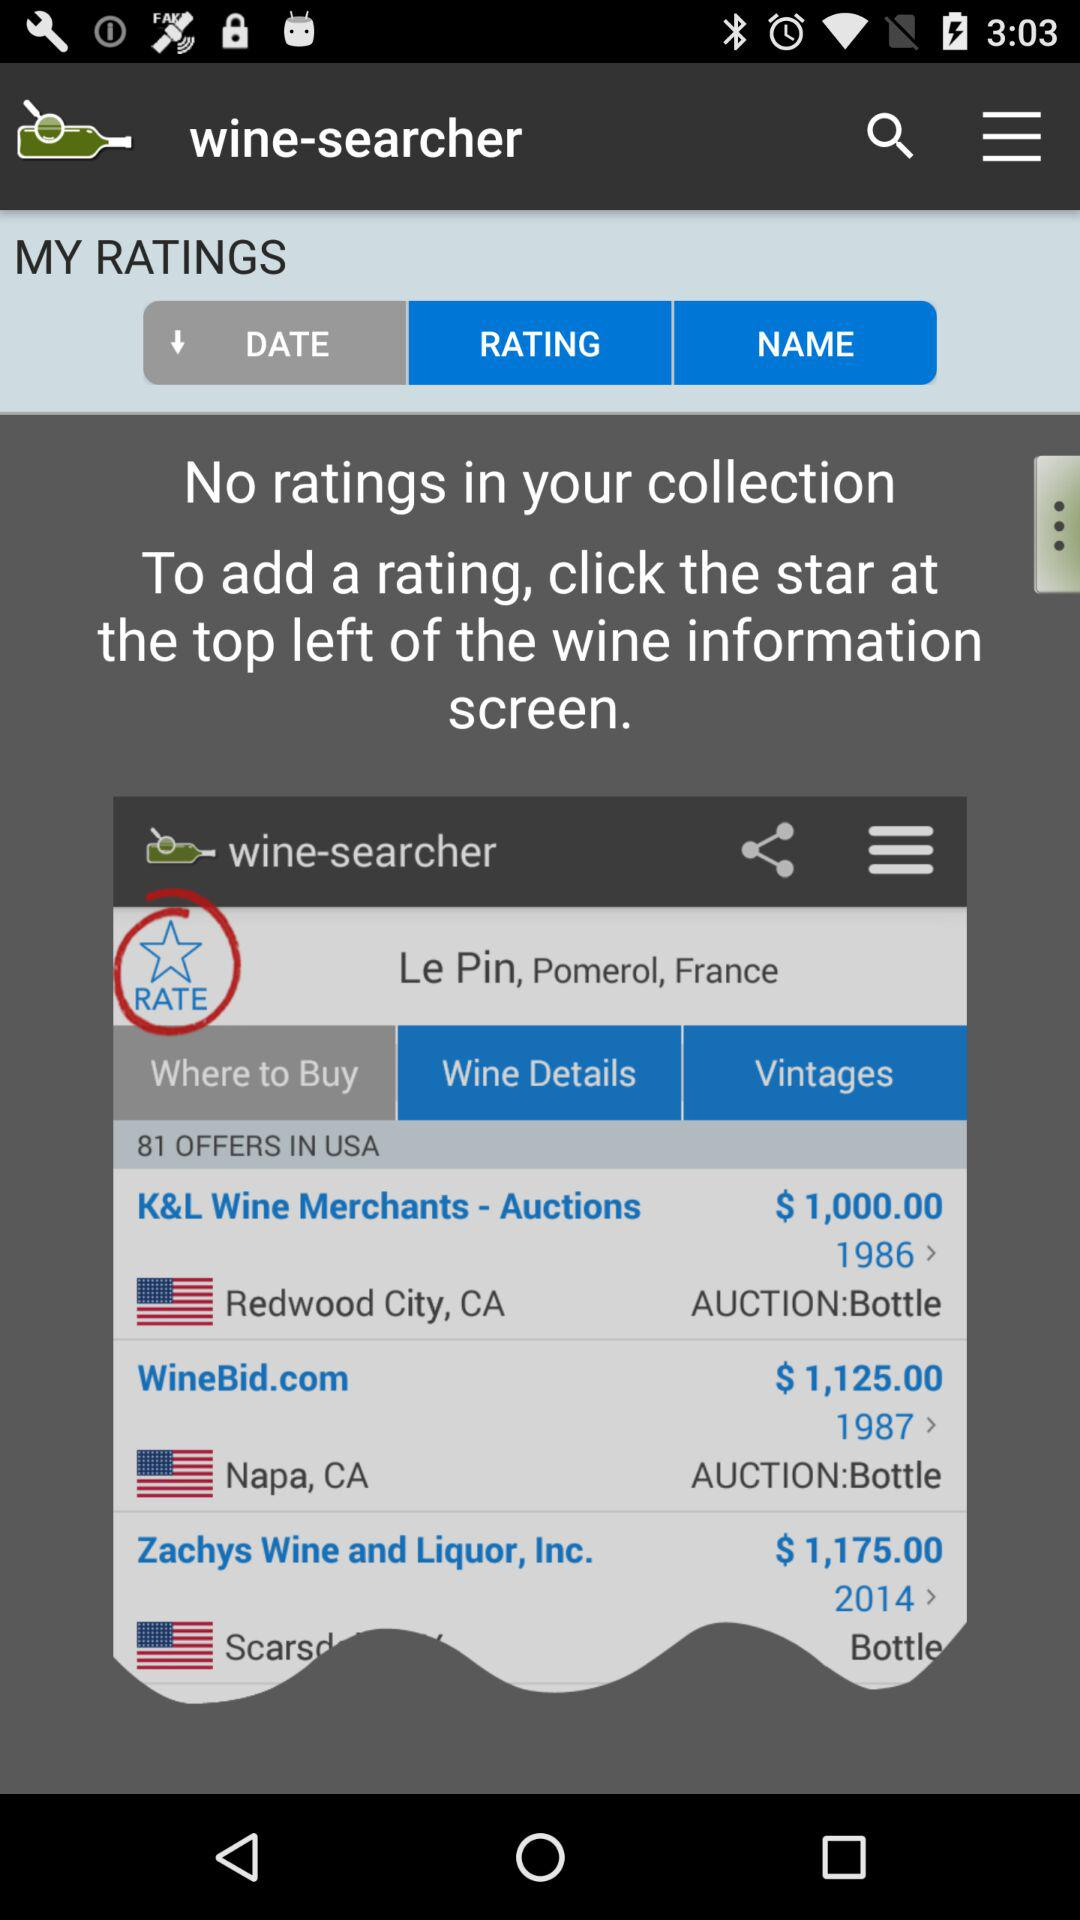What is the name of the application? The name of the application is "wine-searcher". 